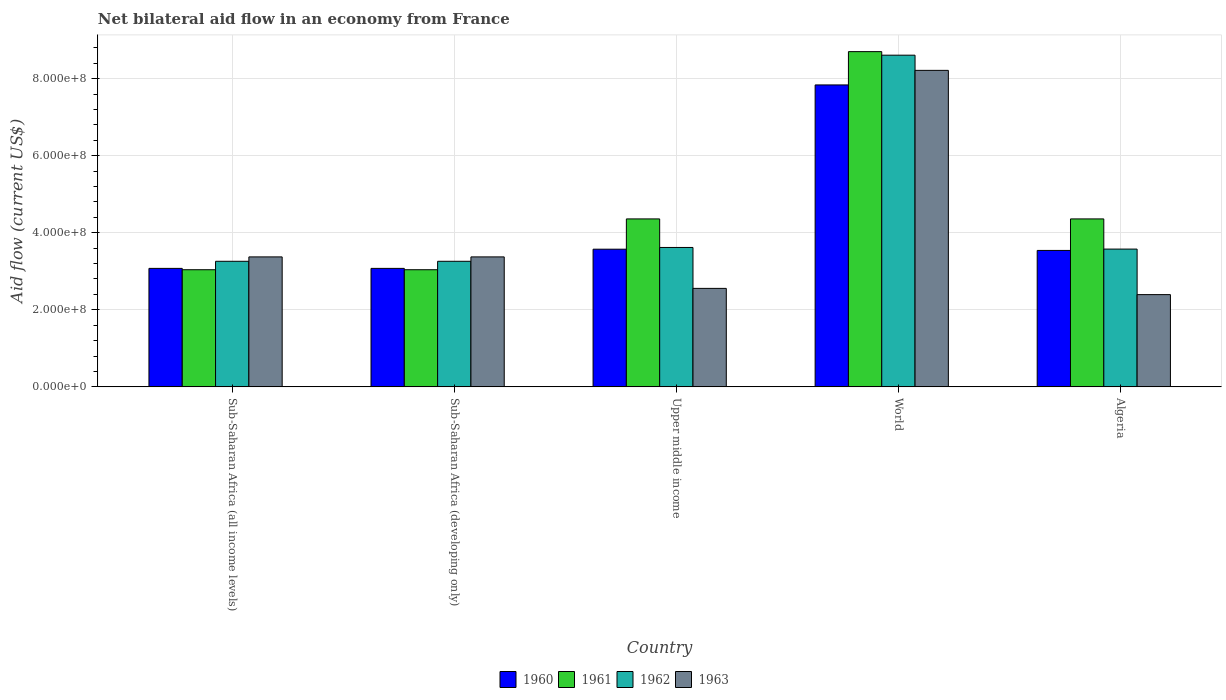Are the number of bars on each tick of the X-axis equal?
Ensure brevity in your answer.  Yes. How many bars are there on the 4th tick from the left?
Give a very brief answer. 4. How many bars are there on the 1st tick from the right?
Offer a terse response. 4. What is the net bilateral aid flow in 1961 in Sub-Saharan Africa (all income levels)?
Your response must be concise. 3.04e+08. Across all countries, what is the maximum net bilateral aid flow in 1960?
Offer a very short reply. 7.84e+08. Across all countries, what is the minimum net bilateral aid flow in 1962?
Ensure brevity in your answer.  3.26e+08. In which country was the net bilateral aid flow in 1961 maximum?
Make the answer very short. World. In which country was the net bilateral aid flow in 1963 minimum?
Offer a very short reply. Algeria. What is the total net bilateral aid flow in 1962 in the graph?
Give a very brief answer. 2.23e+09. What is the difference between the net bilateral aid flow in 1961 in Sub-Saharan Africa (all income levels) and that in Upper middle income?
Ensure brevity in your answer.  -1.32e+08. What is the difference between the net bilateral aid flow in 1961 in Sub-Saharan Africa (all income levels) and the net bilateral aid flow in 1963 in World?
Your answer should be compact. -5.17e+08. What is the average net bilateral aid flow in 1960 per country?
Your response must be concise. 4.22e+08. What is the difference between the net bilateral aid flow of/in 1962 and net bilateral aid flow of/in 1963 in Upper middle income?
Offer a very short reply. 1.06e+08. What is the ratio of the net bilateral aid flow in 1960 in Algeria to that in Upper middle income?
Offer a terse response. 0.99. Is the difference between the net bilateral aid flow in 1962 in Sub-Saharan Africa (all income levels) and World greater than the difference between the net bilateral aid flow in 1963 in Sub-Saharan Africa (all income levels) and World?
Offer a very short reply. No. What is the difference between the highest and the second highest net bilateral aid flow in 1960?
Keep it short and to the point. 4.26e+08. What is the difference between the highest and the lowest net bilateral aid flow in 1963?
Ensure brevity in your answer.  5.82e+08. Is the sum of the net bilateral aid flow in 1962 in Upper middle income and World greater than the maximum net bilateral aid flow in 1963 across all countries?
Keep it short and to the point. Yes. What does the 4th bar from the left in Sub-Saharan Africa (all income levels) represents?
Provide a succinct answer. 1963. Is it the case that in every country, the sum of the net bilateral aid flow in 1960 and net bilateral aid flow in 1961 is greater than the net bilateral aid flow in 1962?
Your answer should be very brief. Yes. How many countries are there in the graph?
Your answer should be very brief. 5. What is the difference between two consecutive major ticks on the Y-axis?
Ensure brevity in your answer.  2.00e+08. Are the values on the major ticks of Y-axis written in scientific E-notation?
Provide a succinct answer. Yes. Does the graph contain grids?
Ensure brevity in your answer.  Yes. Where does the legend appear in the graph?
Offer a terse response. Bottom center. How many legend labels are there?
Your answer should be very brief. 4. How are the legend labels stacked?
Your answer should be compact. Horizontal. What is the title of the graph?
Your answer should be compact. Net bilateral aid flow in an economy from France. Does "1983" appear as one of the legend labels in the graph?
Offer a very short reply. No. What is the Aid flow (current US$) in 1960 in Sub-Saharan Africa (all income levels)?
Provide a succinct answer. 3.08e+08. What is the Aid flow (current US$) of 1961 in Sub-Saharan Africa (all income levels)?
Provide a short and direct response. 3.04e+08. What is the Aid flow (current US$) of 1962 in Sub-Saharan Africa (all income levels)?
Keep it short and to the point. 3.26e+08. What is the Aid flow (current US$) in 1963 in Sub-Saharan Africa (all income levels)?
Give a very brief answer. 3.37e+08. What is the Aid flow (current US$) of 1960 in Sub-Saharan Africa (developing only)?
Offer a very short reply. 3.08e+08. What is the Aid flow (current US$) of 1961 in Sub-Saharan Africa (developing only)?
Give a very brief answer. 3.04e+08. What is the Aid flow (current US$) in 1962 in Sub-Saharan Africa (developing only)?
Offer a terse response. 3.26e+08. What is the Aid flow (current US$) of 1963 in Sub-Saharan Africa (developing only)?
Your answer should be compact. 3.37e+08. What is the Aid flow (current US$) in 1960 in Upper middle income?
Give a very brief answer. 3.57e+08. What is the Aid flow (current US$) of 1961 in Upper middle income?
Offer a terse response. 4.36e+08. What is the Aid flow (current US$) of 1962 in Upper middle income?
Offer a terse response. 3.62e+08. What is the Aid flow (current US$) of 1963 in Upper middle income?
Offer a very short reply. 2.56e+08. What is the Aid flow (current US$) in 1960 in World?
Ensure brevity in your answer.  7.84e+08. What is the Aid flow (current US$) of 1961 in World?
Offer a terse response. 8.70e+08. What is the Aid flow (current US$) in 1962 in World?
Offer a terse response. 8.61e+08. What is the Aid flow (current US$) in 1963 in World?
Ensure brevity in your answer.  8.21e+08. What is the Aid flow (current US$) of 1960 in Algeria?
Your answer should be compact. 3.54e+08. What is the Aid flow (current US$) of 1961 in Algeria?
Your response must be concise. 4.36e+08. What is the Aid flow (current US$) of 1962 in Algeria?
Provide a succinct answer. 3.58e+08. What is the Aid flow (current US$) of 1963 in Algeria?
Your answer should be compact. 2.39e+08. Across all countries, what is the maximum Aid flow (current US$) of 1960?
Make the answer very short. 7.84e+08. Across all countries, what is the maximum Aid flow (current US$) of 1961?
Give a very brief answer. 8.70e+08. Across all countries, what is the maximum Aid flow (current US$) of 1962?
Ensure brevity in your answer.  8.61e+08. Across all countries, what is the maximum Aid flow (current US$) in 1963?
Keep it short and to the point. 8.21e+08. Across all countries, what is the minimum Aid flow (current US$) of 1960?
Your answer should be compact. 3.08e+08. Across all countries, what is the minimum Aid flow (current US$) in 1961?
Your response must be concise. 3.04e+08. Across all countries, what is the minimum Aid flow (current US$) in 1962?
Your answer should be compact. 3.26e+08. Across all countries, what is the minimum Aid flow (current US$) of 1963?
Give a very brief answer. 2.39e+08. What is the total Aid flow (current US$) in 1960 in the graph?
Offer a very short reply. 2.11e+09. What is the total Aid flow (current US$) in 1961 in the graph?
Your response must be concise. 2.35e+09. What is the total Aid flow (current US$) in 1962 in the graph?
Offer a very short reply. 2.23e+09. What is the total Aid flow (current US$) of 1963 in the graph?
Make the answer very short. 1.99e+09. What is the difference between the Aid flow (current US$) in 1963 in Sub-Saharan Africa (all income levels) and that in Sub-Saharan Africa (developing only)?
Offer a terse response. 0. What is the difference between the Aid flow (current US$) of 1960 in Sub-Saharan Africa (all income levels) and that in Upper middle income?
Provide a succinct answer. -4.98e+07. What is the difference between the Aid flow (current US$) of 1961 in Sub-Saharan Africa (all income levels) and that in Upper middle income?
Offer a very short reply. -1.32e+08. What is the difference between the Aid flow (current US$) in 1962 in Sub-Saharan Africa (all income levels) and that in Upper middle income?
Give a very brief answer. -3.59e+07. What is the difference between the Aid flow (current US$) in 1963 in Sub-Saharan Africa (all income levels) and that in Upper middle income?
Your response must be concise. 8.17e+07. What is the difference between the Aid flow (current US$) in 1960 in Sub-Saharan Africa (all income levels) and that in World?
Ensure brevity in your answer.  -4.76e+08. What is the difference between the Aid flow (current US$) in 1961 in Sub-Saharan Africa (all income levels) and that in World?
Your response must be concise. -5.66e+08. What is the difference between the Aid flow (current US$) of 1962 in Sub-Saharan Africa (all income levels) and that in World?
Your response must be concise. -5.35e+08. What is the difference between the Aid flow (current US$) of 1963 in Sub-Saharan Africa (all income levels) and that in World?
Give a very brief answer. -4.84e+08. What is the difference between the Aid flow (current US$) in 1960 in Sub-Saharan Africa (all income levels) and that in Algeria?
Offer a very short reply. -4.66e+07. What is the difference between the Aid flow (current US$) of 1961 in Sub-Saharan Africa (all income levels) and that in Algeria?
Your response must be concise. -1.32e+08. What is the difference between the Aid flow (current US$) in 1962 in Sub-Saharan Africa (all income levels) and that in Algeria?
Provide a succinct answer. -3.17e+07. What is the difference between the Aid flow (current US$) of 1963 in Sub-Saharan Africa (all income levels) and that in Algeria?
Provide a succinct answer. 9.79e+07. What is the difference between the Aid flow (current US$) in 1960 in Sub-Saharan Africa (developing only) and that in Upper middle income?
Offer a very short reply. -4.98e+07. What is the difference between the Aid flow (current US$) in 1961 in Sub-Saharan Africa (developing only) and that in Upper middle income?
Keep it short and to the point. -1.32e+08. What is the difference between the Aid flow (current US$) in 1962 in Sub-Saharan Africa (developing only) and that in Upper middle income?
Offer a very short reply. -3.59e+07. What is the difference between the Aid flow (current US$) of 1963 in Sub-Saharan Africa (developing only) and that in Upper middle income?
Keep it short and to the point. 8.17e+07. What is the difference between the Aid flow (current US$) in 1960 in Sub-Saharan Africa (developing only) and that in World?
Give a very brief answer. -4.76e+08. What is the difference between the Aid flow (current US$) of 1961 in Sub-Saharan Africa (developing only) and that in World?
Your answer should be compact. -5.66e+08. What is the difference between the Aid flow (current US$) of 1962 in Sub-Saharan Africa (developing only) and that in World?
Offer a very short reply. -5.35e+08. What is the difference between the Aid flow (current US$) of 1963 in Sub-Saharan Africa (developing only) and that in World?
Keep it short and to the point. -4.84e+08. What is the difference between the Aid flow (current US$) of 1960 in Sub-Saharan Africa (developing only) and that in Algeria?
Give a very brief answer. -4.66e+07. What is the difference between the Aid flow (current US$) in 1961 in Sub-Saharan Africa (developing only) and that in Algeria?
Keep it short and to the point. -1.32e+08. What is the difference between the Aid flow (current US$) in 1962 in Sub-Saharan Africa (developing only) and that in Algeria?
Provide a succinct answer. -3.17e+07. What is the difference between the Aid flow (current US$) in 1963 in Sub-Saharan Africa (developing only) and that in Algeria?
Ensure brevity in your answer.  9.79e+07. What is the difference between the Aid flow (current US$) in 1960 in Upper middle income and that in World?
Keep it short and to the point. -4.26e+08. What is the difference between the Aid flow (current US$) of 1961 in Upper middle income and that in World?
Provide a succinct answer. -4.34e+08. What is the difference between the Aid flow (current US$) in 1962 in Upper middle income and that in World?
Your answer should be compact. -4.99e+08. What is the difference between the Aid flow (current US$) of 1963 in Upper middle income and that in World?
Provide a short and direct response. -5.66e+08. What is the difference between the Aid flow (current US$) in 1960 in Upper middle income and that in Algeria?
Your response must be concise. 3.20e+06. What is the difference between the Aid flow (current US$) in 1962 in Upper middle income and that in Algeria?
Ensure brevity in your answer.  4.20e+06. What is the difference between the Aid flow (current US$) in 1963 in Upper middle income and that in Algeria?
Provide a succinct answer. 1.62e+07. What is the difference between the Aid flow (current US$) of 1960 in World and that in Algeria?
Your response must be concise. 4.30e+08. What is the difference between the Aid flow (current US$) of 1961 in World and that in Algeria?
Your response must be concise. 4.34e+08. What is the difference between the Aid flow (current US$) of 1962 in World and that in Algeria?
Offer a very short reply. 5.03e+08. What is the difference between the Aid flow (current US$) in 1963 in World and that in Algeria?
Provide a short and direct response. 5.82e+08. What is the difference between the Aid flow (current US$) in 1960 in Sub-Saharan Africa (all income levels) and the Aid flow (current US$) in 1961 in Sub-Saharan Africa (developing only)?
Give a very brief answer. 3.50e+06. What is the difference between the Aid flow (current US$) in 1960 in Sub-Saharan Africa (all income levels) and the Aid flow (current US$) in 1962 in Sub-Saharan Africa (developing only)?
Your answer should be compact. -1.84e+07. What is the difference between the Aid flow (current US$) of 1960 in Sub-Saharan Africa (all income levels) and the Aid flow (current US$) of 1963 in Sub-Saharan Africa (developing only)?
Your answer should be compact. -2.98e+07. What is the difference between the Aid flow (current US$) of 1961 in Sub-Saharan Africa (all income levels) and the Aid flow (current US$) of 1962 in Sub-Saharan Africa (developing only)?
Your response must be concise. -2.19e+07. What is the difference between the Aid flow (current US$) in 1961 in Sub-Saharan Africa (all income levels) and the Aid flow (current US$) in 1963 in Sub-Saharan Africa (developing only)?
Make the answer very short. -3.33e+07. What is the difference between the Aid flow (current US$) of 1962 in Sub-Saharan Africa (all income levels) and the Aid flow (current US$) of 1963 in Sub-Saharan Africa (developing only)?
Offer a terse response. -1.14e+07. What is the difference between the Aid flow (current US$) of 1960 in Sub-Saharan Africa (all income levels) and the Aid flow (current US$) of 1961 in Upper middle income?
Make the answer very short. -1.28e+08. What is the difference between the Aid flow (current US$) of 1960 in Sub-Saharan Africa (all income levels) and the Aid flow (current US$) of 1962 in Upper middle income?
Your answer should be very brief. -5.43e+07. What is the difference between the Aid flow (current US$) in 1960 in Sub-Saharan Africa (all income levels) and the Aid flow (current US$) in 1963 in Upper middle income?
Ensure brevity in your answer.  5.19e+07. What is the difference between the Aid flow (current US$) in 1961 in Sub-Saharan Africa (all income levels) and the Aid flow (current US$) in 1962 in Upper middle income?
Provide a succinct answer. -5.78e+07. What is the difference between the Aid flow (current US$) in 1961 in Sub-Saharan Africa (all income levels) and the Aid flow (current US$) in 1963 in Upper middle income?
Your response must be concise. 4.84e+07. What is the difference between the Aid flow (current US$) in 1962 in Sub-Saharan Africa (all income levels) and the Aid flow (current US$) in 1963 in Upper middle income?
Your answer should be compact. 7.03e+07. What is the difference between the Aid flow (current US$) of 1960 in Sub-Saharan Africa (all income levels) and the Aid flow (current US$) of 1961 in World?
Give a very brief answer. -5.62e+08. What is the difference between the Aid flow (current US$) of 1960 in Sub-Saharan Africa (all income levels) and the Aid flow (current US$) of 1962 in World?
Give a very brief answer. -5.53e+08. What is the difference between the Aid flow (current US$) of 1960 in Sub-Saharan Africa (all income levels) and the Aid flow (current US$) of 1963 in World?
Make the answer very short. -5.14e+08. What is the difference between the Aid flow (current US$) in 1961 in Sub-Saharan Africa (all income levels) and the Aid flow (current US$) in 1962 in World?
Your response must be concise. -5.57e+08. What is the difference between the Aid flow (current US$) in 1961 in Sub-Saharan Africa (all income levels) and the Aid flow (current US$) in 1963 in World?
Your response must be concise. -5.17e+08. What is the difference between the Aid flow (current US$) of 1962 in Sub-Saharan Africa (all income levels) and the Aid flow (current US$) of 1963 in World?
Give a very brief answer. -4.96e+08. What is the difference between the Aid flow (current US$) of 1960 in Sub-Saharan Africa (all income levels) and the Aid flow (current US$) of 1961 in Algeria?
Your answer should be very brief. -1.28e+08. What is the difference between the Aid flow (current US$) of 1960 in Sub-Saharan Africa (all income levels) and the Aid flow (current US$) of 1962 in Algeria?
Make the answer very short. -5.01e+07. What is the difference between the Aid flow (current US$) in 1960 in Sub-Saharan Africa (all income levels) and the Aid flow (current US$) in 1963 in Algeria?
Your answer should be very brief. 6.81e+07. What is the difference between the Aid flow (current US$) of 1961 in Sub-Saharan Africa (all income levels) and the Aid flow (current US$) of 1962 in Algeria?
Offer a terse response. -5.36e+07. What is the difference between the Aid flow (current US$) in 1961 in Sub-Saharan Africa (all income levels) and the Aid flow (current US$) in 1963 in Algeria?
Your response must be concise. 6.46e+07. What is the difference between the Aid flow (current US$) of 1962 in Sub-Saharan Africa (all income levels) and the Aid flow (current US$) of 1963 in Algeria?
Your answer should be very brief. 8.65e+07. What is the difference between the Aid flow (current US$) of 1960 in Sub-Saharan Africa (developing only) and the Aid flow (current US$) of 1961 in Upper middle income?
Your answer should be compact. -1.28e+08. What is the difference between the Aid flow (current US$) in 1960 in Sub-Saharan Africa (developing only) and the Aid flow (current US$) in 1962 in Upper middle income?
Ensure brevity in your answer.  -5.43e+07. What is the difference between the Aid flow (current US$) of 1960 in Sub-Saharan Africa (developing only) and the Aid flow (current US$) of 1963 in Upper middle income?
Offer a terse response. 5.19e+07. What is the difference between the Aid flow (current US$) of 1961 in Sub-Saharan Africa (developing only) and the Aid flow (current US$) of 1962 in Upper middle income?
Offer a very short reply. -5.78e+07. What is the difference between the Aid flow (current US$) in 1961 in Sub-Saharan Africa (developing only) and the Aid flow (current US$) in 1963 in Upper middle income?
Your answer should be compact. 4.84e+07. What is the difference between the Aid flow (current US$) in 1962 in Sub-Saharan Africa (developing only) and the Aid flow (current US$) in 1963 in Upper middle income?
Provide a succinct answer. 7.03e+07. What is the difference between the Aid flow (current US$) in 1960 in Sub-Saharan Africa (developing only) and the Aid flow (current US$) in 1961 in World?
Make the answer very short. -5.62e+08. What is the difference between the Aid flow (current US$) in 1960 in Sub-Saharan Africa (developing only) and the Aid flow (current US$) in 1962 in World?
Your answer should be very brief. -5.53e+08. What is the difference between the Aid flow (current US$) in 1960 in Sub-Saharan Africa (developing only) and the Aid flow (current US$) in 1963 in World?
Provide a succinct answer. -5.14e+08. What is the difference between the Aid flow (current US$) of 1961 in Sub-Saharan Africa (developing only) and the Aid flow (current US$) of 1962 in World?
Your answer should be very brief. -5.57e+08. What is the difference between the Aid flow (current US$) of 1961 in Sub-Saharan Africa (developing only) and the Aid flow (current US$) of 1963 in World?
Ensure brevity in your answer.  -5.17e+08. What is the difference between the Aid flow (current US$) in 1962 in Sub-Saharan Africa (developing only) and the Aid flow (current US$) in 1963 in World?
Keep it short and to the point. -4.96e+08. What is the difference between the Aid flow (current US$) in 1960 in Sub-Saharan Africa (developing only) and the Aid flow (current US$) in 1961 in Algeria?
Your answer should be compact. -1.28e+08. What is the difference between the Aid flow (current US$) of 1960 in Sub-Saharan Africa (developing only) and the Aid flow (current US$) of 1962 in Algeria?
Make the answer very short. -5.01e+07. What is the difference between the Aid flow (current US$) of 1960 in Sub-Saharan Africa (developing only) and the Aid flow (current US$) of 1963 in Algeria?
Your response must be concise. 6.81e+07. What is the difference between the Aid flow (current US$) in 1961 in Sub-Saharan Africa (developing only) and the Aid flow (current US$) in 1962 in Algeria?
Keep it short and to the point. -5.36e+07. What is the difference between the Aid flow (current US$) of 1961 in Sub-Saharan Africa (developing only) and the Aid flow (current US$) of 1963 in Algeria?
Your response must be concise. 6.46e+07. What is the difference between the Aid flow (current US$) of 1962 in Sub-Saharan Africa (developing only) and the Aid flow (current US$) of 1963 in Algeria?
Your answer should be very brief. 8.65e+07. What is the difference between the Aid flow (current US$) of 1960 in Upper middle income and the Aid flow (current US$) of 1961 in World?
Keep it short and to the point. -5.13e+08. What is the difference between the Aid flow (current US$) of 1960 in Upper middle income and the Aid flow (current US$) of 1962 in World?
Give a very brief answer. -5.04e+08. What is the difference between the Aid flow (current US$) of 1960 in Upper middle income and the Aid flow (current US$) of 1963 in World?
Your response must be concise. -4.64e+08. What is the difference between the Aid flow (current US$) in 1961 in Upper middle income and the Aid flow (current US$) in 1962 in World?
Give a very brief answer. -4.25e+08. What is the difference between the Aid flow (current US$) in 1961 in Upper middle income and the Aid flow (current US$) in 1963 in World?
Your response must be concise. -3.86e+08. What is the difference between the Aid flow (current US$) in 1962 in Upper middle income and the Aid flow (current US$) in 1963 in World?
Offer a very short reply. -4.60e+08. What is the difference between the Aid flow (current US$) of 1960 in Upper middle income and the Aid flow (current US$) of 1961 in Algeria?
Provide a short and direct response. -7.86e+07. What is the difference between the Aid flow (current US$) of 1960 in Upper middle income and the Aid flow (current US$) of 1962 in Algeria?
Keep it short and to the point. -3.00e+05. What is the difference between the Aid flow (current US$) in 1960 in Upper middle income and the Aid flow (current US$) in 1963 in Algeria?
Keep it short and to the point. 1.18e+08. What is the difference between the Aid flow (current US$) of 1961 in Upper middle income and the Aid flow (current US$) of 1962 in Algeria?
Offer a very short reply. 7.83e+07. What is the difference between the Aid flow (current US$) in 1961 in Upper middle income and the Aid flow (current US$) in 1963 in Algeria?
Your response must be concise. 1.96e+08. What is the difference between the Aid flow (current US$) in 1962 in Upper middle income and the Aid flow (current US$) in 1963 in Algeria?
Your response must be concise. 1.22e+08. What is the difference between the Aid flow (current US$) in 1960 in World and the Aid flow (current US$) in 1961 in Algeria?
Keep it short and to the point. 3.48e+08. What is the difference between the Aid flow (current US$) in 1960 in World and the Aid flow (current US$) in 1962 in Algeria?
Give a very brief answer. 4.26e+08. What is the difference between the Aid flow (current US$) of 1960 in World and the Aid flow (current US$) of 1963 in Algeria?
Give a very brief answer. 5.44e+08. What is the difference between the Aid flow (current US$) of 1961 in World and the Aid flow (current US$) of 1962 in Algeria?
Give a very brief answer. 5.12e+08. What is the difference between the Aid flow (current US$) of 1961 in World and the Aid flow (current US$) of 1963 in Algeria?
Offer a very short reply. 6.31e+08. What is the difference between the Aid flow (current US$) in 1962 in World and the Aid flow (current US$) in 1963 in Algeria?
Give a very brief answer. 6.21e+08. What is the average Aid flow (current US$) of 1960 per country?
Your response must be concise. 4.22e+08. What is the average Aid flow (current US$) of 1961 per country?
Your answer should be compact. 4.70e+08. What is the average Aid flow (current US$) in 1962 per country?
Keep it short and to the point. 4.46e+08. What is the average Aid flow (current US$) in 1963 per country?
Keep it short and to the point. 3.98e+08. What is the difference between the Aid flow (current US$) of 1960 and Aid flow (current US$) of 1961 in Sub-Saharan Africa (all income levels)?
Ensure brevity in your answer.  3.50e+06. What is the difference between the Aid flow (current US$) of 1960 and Aid flow (current US$) of 1962 in Sub-Saharan Africa (all income levels)?
Your response must be concise. -1.84e+07. What is the difference between the Aid flow (current US$) in 1960 and Aid flow (current US$) in 1963 in Sub-Saharan Africa (all income levels)?
Give a very brief answer. -2.98e+07. What is the difference between the Aid flow (current US$) in 1961 and Aid flow (current US$) in 1962 in Sub-Saharan Africa (all income levels)?
Your answer should be compact. -2.19e+07. What is the difference between the Aid flow (current US$) of 1961 and Aid flow (current US$) of 1963 in Sub-Saharan Africa (all income levels)?
Ensure brevity in your answer.  -3.33e+07. What is the difference between the Aid flow (current US$) of 1962 and Aid flow (current US$) of 1963 in Sub-Saharan Africa (all income levels)?
Give a very brief answer. -1.14e+07. What is the difference between the Aid flow (current US$) in 1960 and Aid flow (current US$) in 1961 in Sub-Saharan Africa (developing only)?
Your answer should be compact. 3.50e+06. What is the difference between the Aid flow (current US$) in 1960 and Aid flow (current US$) in 1962 in Sub-Saharan Africa (developing only)?
Provide a succinct answer. -1.84e+07. What is the difference between the Aid flow (current US$) of 1960 and Aid flow (current US$) of 1963 in Sub-Saharan Africa (developing only)?
Ensure brevity in your answer.  -2.98e+07. What is the difference between the Aid flow (current US$) in 1961 and Aid flow (current US$) in 1962 in Sub-Saharan Africa (developing only)?
Your response must be concise. -2.19e+07. What is the difference between the Aid flow (current US$) of 1961 and Aid flow (current US$) of 1963 in Sub-Saharan Africa (developing only)?
Your response must be concise. -3.33e+07. What is the difference between the Aid flow (current US$) in 1962 and Aid flow (current US$) in 1963 in Sub-Saharan Africa (developing only)?
Offer a very short reply. -1.14e+07. What is the difference between the Aid flow (current US$) in 1960 and Aid flow (current US$) in 1961 in Upper middle income?
Ensure brevity in your answer.  -7.86e+07. What is the difference between the Aid flow (current US$) in 1960 and Aid flow (current US$) in 1962 in Upper middle income?
Your answer should be compact. -4.50e+06. What is the difference between the Aid flow (current US$) of 1960 and Aid flow (current US$) of 1963 in Upper middle income?
Your answer should be compact. 1.02e+08. What is the difference between the Aid flow (current US$) in 1961 and Aid flow (current US$) in 1962 in Upper middle income?
Give a very brief answer. 7.41e+07. What is the difference between the Aid flow (current US$) in 1961 and Aid flow (current US$) in 1963 in Upper middle income?
Your answer should be very brief. 1.80e+08. What is the difference between the Aid flow (current US$) of 1962 and Aid flow (current US$) of 1963 in Upper middle income?
Ensure brevity in your answer.  1.06e+08. What is the difference between the Aid flow (current US$) of 1960 and Aid flow (current US$) of 1961 in World?
Offer a very short reply. -8.64e+07. What is the difference between the Aid flow (current US$) in 1960 and Aid flow (current US$) in 1962 in World?
Provide a short and direct response. -7.72e+07. What is the difference between the Aid flow (current US$) of 1960 and Aid flow (current US$) of 1963 in World?
Offer a terse response. -3.78e+07. What is the difference between the Aid flow (current US$) in 1961 and Aid flow (current US$) in 1962 in World?
Keep it short and to the point. 9.20e+06. What is the difference between the Aid flow (current US$) in 1961 and Aid flow (current US$) in 1963 in World?
Offer a very short reply. 4.86e+07. What is the difference between the Aid flow (current US$) in 1962 and Aid flow (current US$) in 1963 in World?
Your response must be concise. 3.94e+07. What is the difference between the Aid flow (current US$) of 1960 and Aid flow (current US$) of 1961 in Algeria?
Ensure brevity in your answer.  -8.18e+07. What is the difference between the Aid flow (current US$) in 1960 and Aid flow (current US$) in 1962 in Algeria?
Give a very brief answer. -3.50e+06. What is the difference between the Aid flow (current US$) of 1960 and Aid flow (current US$) of 1963 in Algeria?
Provide a succinct answer. 1.15e+08. What is the difference between the Aid flow (current US$) of 1961 and Aid flow (current US$) of 1962 in Algeria?
Offer a terse response. 7.83e+07. What is the difference between the Aid flow (current US$) in 1961 and Aid flow (current US$) in 1963 in Algeria?
Provide a succinct answer. 1.96e+08. What is the difference between the Aid flow (current US$) in 1962 and Aid flow (current US$) in 1963 in Algeria?
Provide a succinct answer. 1.18e+08. What is the ratio of the Aid flow (current US$) of 1960 in Sub-Saharan Africa (all income levels) to that in Sub-Saharan Africa (developing only)?
Provide a succinct answer. 1. What is the ratio of the Aid flow (current US$) in 1962 in Sub-Saharan Africa (all income levels) to that in Sub-Saharan Africa (developing only)?
Keep it short and to the point. 1. What is the ratio of the Aid flow (current US$) in 1963 in Sub-Saharan Africa (all income levels) to that in Sub-Saharan Africa (developing only)?
Your response must be concise. 1. What is the ratio of the Aid flow (current US$) in 1960 in Sub-Saharan Africa (all income levels) to that in Upper middle income?
Your response must be concise. 0.86. What is the ratio of the Aid flow (current US$) in 1961 in Sub-Saharan Africa (all income levels) to that in Upper middle income?
Offer a very short reply. 0.7. What is the ratio of the Aid flow (current US$) of 1962 in Sub-Saharan Africa (all income levels) to that in Upper middle income?
Provide a short and direct response. 0.9. What is the ratio of the Aid flow (current US$) in 1963 in Sub-Saharan Africa (all income levels) to that in Upper middle income?
Provide a succinct answer. 1.32. What is the ratio of the Aid flow (current US$) of 1960 in Sub-Saharan Africa (all income levels) to that in World?
Make the answer very short. 0.39. What is the ratio of the Aid flow (current US$) of 1961 in Sub-Saharan Africa (all income levels) to that in World?
Your response must be concise. 0.35. What is the ratio of the Aid flow (current US$) of 1962 in Sub-Saharan Africa (all income levels) to that in World?
Provide a succinct answer. 0.38. What is the ratio of the Aid flow (current US$) of 1963 in Sub-Saharan Africa (all income levels) to that in World?
Make the answer very short. 0.41. What is the ratio of the Aid flow (current US$) in 1960 in Sub-Saharan Africa (all income levels) to that in Algeria?
Provide a succinct answer. 0.87. What is the ratio of the Aid flow (current US$) in 1961 in Sub-Saharan Africa (all income levels) to that in Algeria?
Your answer should be very brief. 0.7. What is the ratio of the Aid flow (current US$) of 1962 in Sub-Saharan Africa (all income levels) to that in Algeria?
Offer a very short reply. 0.91. What is the ratio of the Aid flow (current US$) of 1963 in Sub-Saharan Africa (all income levels) to that in Algeria?
Offer a very short reply. 1.41. What is the ratio of the Aid flow (current US$) of 1960 in Sub-Saharan Africa (developing only) to that in Upper middle income?
Your answer should be compact. 0.86. What is the ratio of the Aid flow (current US$) of 1961 in Sub-Saharan Africa (developing only) to that in Upper middle income?
Give a very brief answer. 0.7. What is the ratio of the Aid flow (current US$) of 1962 in Sub-Saharan Africa (developing only) to that in Upper middle income?
Make the answer very short. 0.9. What is the ratio of the Aid flow (current US$) in 1963 in Sub-Saharan Africa (developing only) to that in Upper middle income?
Your answer should be very brief. 1.32. What is the ratio of the Aid flow (current US$) in 1960 in Sub-Saharan Africa (developing only) to that in World?
Your response must be concise. 0.39. What is the ratio of the Aid flow (current US$) in 1961 in Sub-Saharan Africa (developing only) to that in World?
Provide a short and direct response. 0.35. What is the ratio of the Aid flow (current US$) of 1962 in Sub-Saharan Africa (developing only) to that in World?
Keep it short and to the point. 0.38. What is the ratio of the Aid flow (current US$) in 1963 in Sub-Saharan Africa (developing only) to that in World?
Your answer should be very brief. 0.41. What is the ratio of the Aid flow (current US$) in 1960 in Sub-Saharan Africa (developing only) to that in Algeria?
Your answer should be very brief. 0.87. What is the ratio of the Aid flow (current US$) in 1961 in Sub-Saharan Africa (developing only) to that in Algeria?
Provide a succinct answer. 0.7. What is the ratio of the Aid flow (current US$) in 1962 in Sub-Saharan Africa (developing only) to that in Algeria?
Your response must be concise. 0.91. What is the ratio of the Aid flow (current US$) in 1963 in Sub-Saharan Africa (developing only) to that in Algeria?
Your response must be concise. 1.41. What is the ratio of the Aid flow (current US$) of 1960 in Upper middle income to that in World?
Provide a succinct answer. 0.46. What is the ratio of the Aid flow (current US$) of 1961 in Upper middle income to that in World?
Give a very brief answer. 0.5. What is the ratio of the Aid flow (current US$) of 1962 in Upper middle income to that in World?
Provide a short and direct response. 0.42. What is the ratio of the Aid flow (current US$) of 1963 in Upper middle income to that in World?
Provide a succinct answer. 0.31. What is the ratio of the Aid flow (current US$) in 1960 in Upper middle income to that in Algeria?
Provide a succinct answer. 1.01. What is the ratio of the Aid flow (current US$) in 1962 in Upper middle income to that in Algeria?
Make the answer very short. 1.01. What is the ratio of the Aid flow (current US$) in 1963 in Upper middle income to that in Algeria?
Offer a terse response. 1.07. What is the ratio of the Aid flow (current US$) of 1960 in World to that in Algeria?
Your answer should be compact. 2.21. What is the ratio of the Aid flow (current US$) of 1961 in World to that in Algeria?
Your answer should be very brief. 2. What is the ratio of the Aid flow (current US$) in 1962 in World to that in Algeria?
Offer a terse response. 2.41. What is the ratio of the Aid flow (current US$) of 1963 in World to that in Algeria?
Give a very brief answer. 3.43. What is the difference between the highest and the second highest Aid flow (current US$) in 1960?
Your answer should be compact. 4.26e+08. What is the difference between the highest and the second highest Aid flow (current US$) of 1961?
Offer a terse response. 4.34e+08. What is the difference between the highest and the second highest Aid flow (current US$) of 1962?
Your answer should be very brief. 4.99e+08. What is the difference between the highest and the second highest Aid flow (current US$) of 1963?
Your answer should be compact. 4.84e+08. What is the difference between the highest and the lowest Aid flow (current US$) in 1960?
Offer a very short reply. 4.76e+08. What is the difference between the highest and the lowest Aid flow (current US$) in 1961?
Offer a very short reply. 5.66e+08. What is the difference between the highest and the lowest Aid flow (current US$) in 1962?
Your answer should be very brief. 5.35e+08. What is the difference between the highest and the lowest Aid flow (current US$) of 1963?
Ensure brevity in your answer.  5.82e+08. 